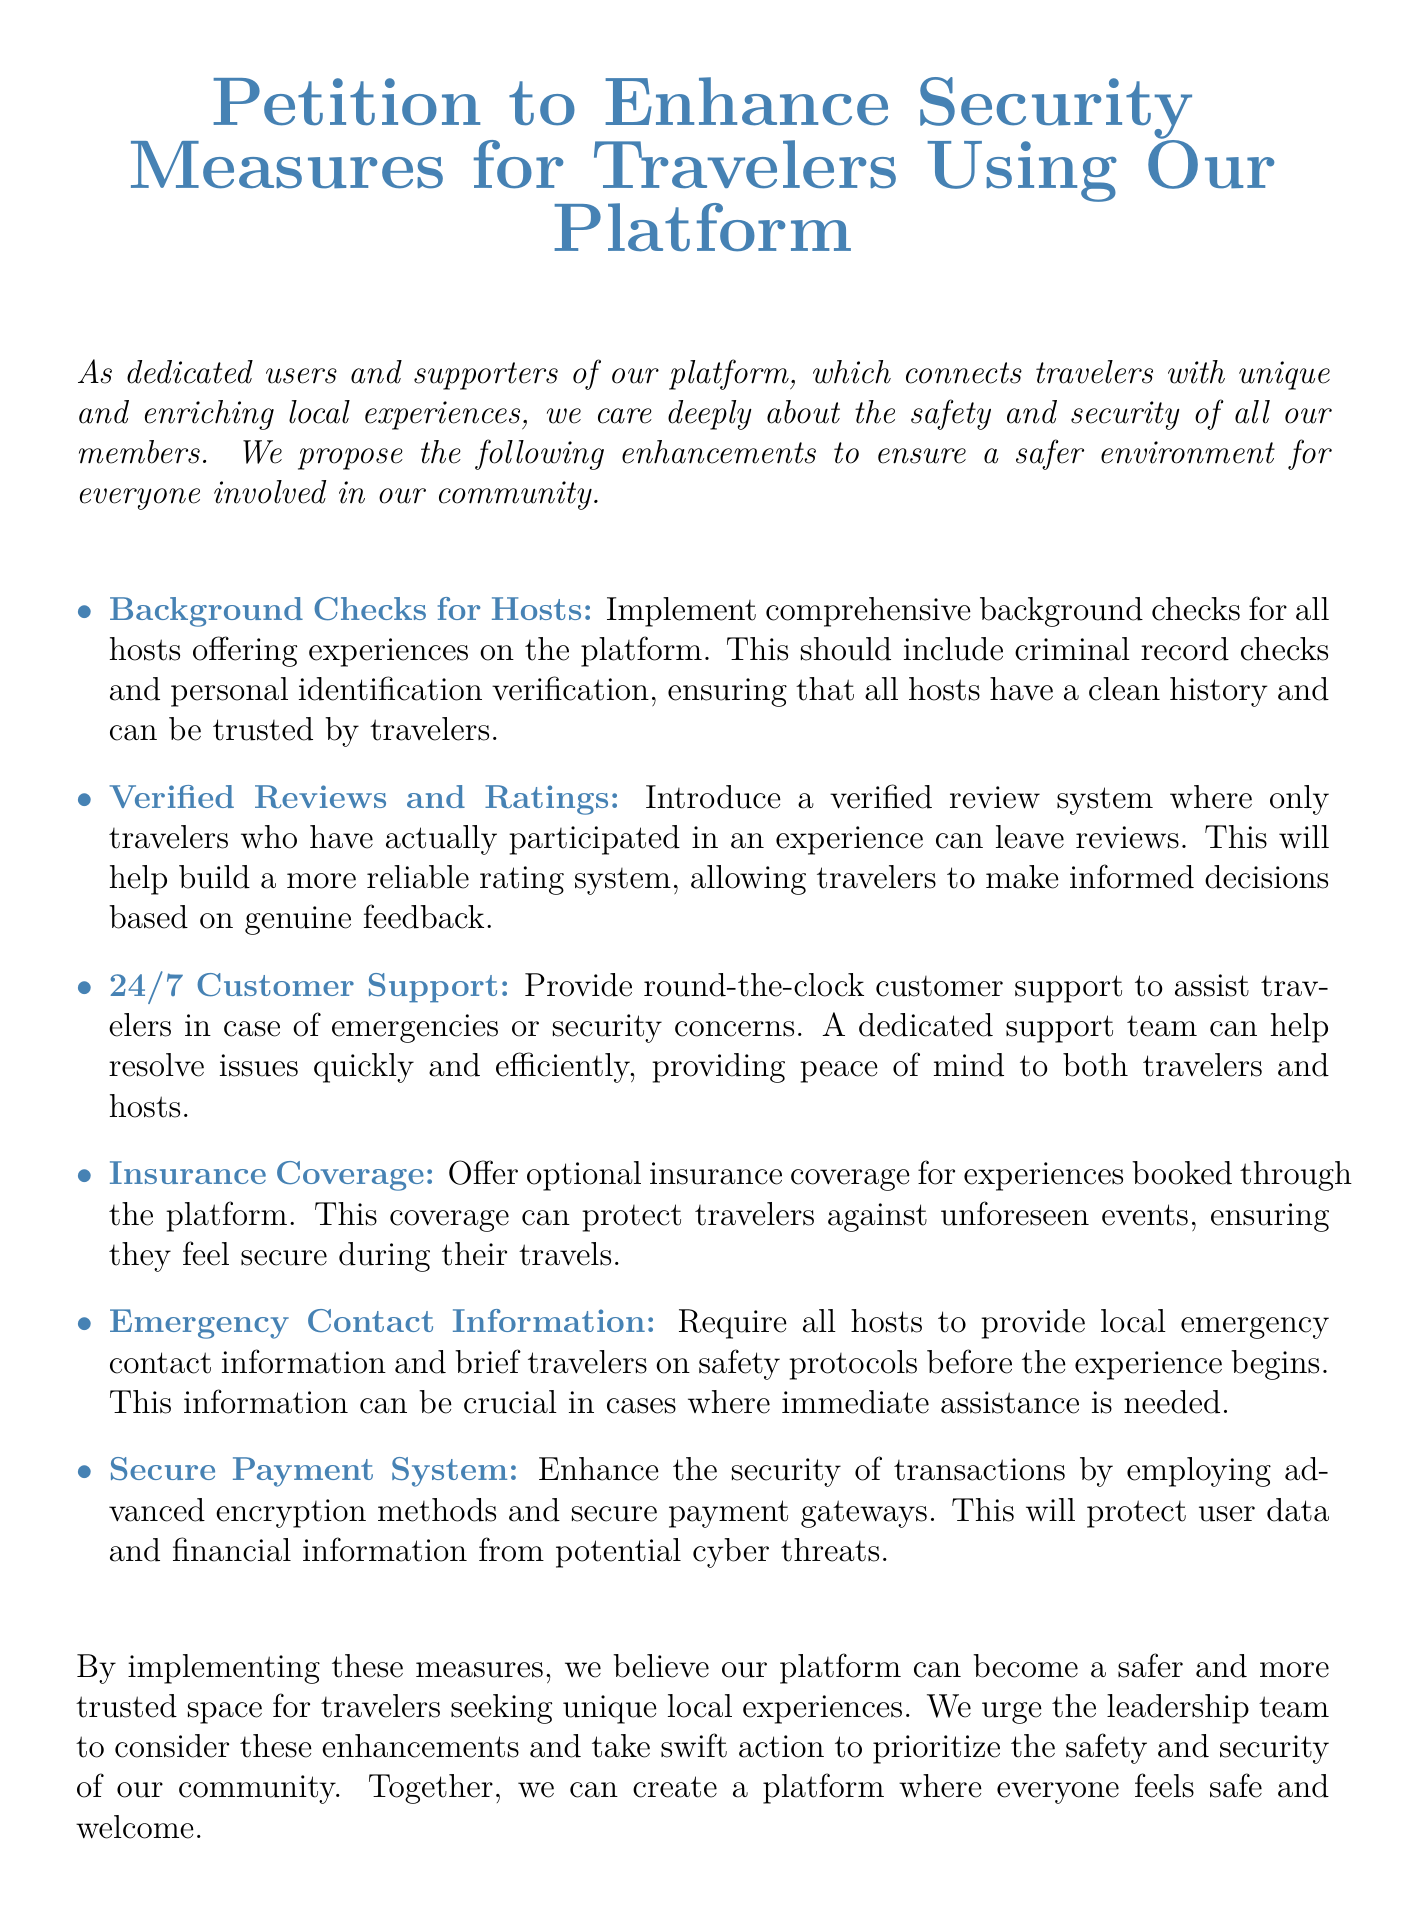What is the title of the petition? The title of the petition is presented prominently at the top of the document, stating its purpose.
Answer: Petition to Enhance Security Measures for Travelers Using Our Platform How many key enhancements are proposed in the petition? The petition lists the key enhancements for security measures which can be counted from the bulleted list provided.
Answer: Six What is one proposed enhancement related to hosts? The petition details measures specifically targeted at hosts, which is mentioned in one of the bullet points.
Answer: Background Checks for Hosts What type of customer support is proposed in the document? The document specifies the type of customer support needed for travelers, which is detailed under one of the enhancements.
Answer: 24/7 Customer Support What is the main goal mentioned in the petition? The overall intention of the petition is explicitly stated in the document's concluding remarks.
Answer: Safer environment What information is required from hosts before experiences? The petition outlines essential information that hosts need to provide for safety purposes in the bullet points.
Answer: Emergency Contact Information What kind of payment system is suggested in the document? The document mentions the type of payment system that should be enhanced, focusing on security aspects.
Answer: Secure Payment System What does the petition urge the leadership team to do? The final remarks of the document encapsulate the action the petitioners are encouraging from the leadership team.
Answer: Consider enhancements What kind of coverage is suggested for travelers? The petition mentions an optional type of coverage to enhance security for travelers during experiences.
Answer: Insurance Coverage 